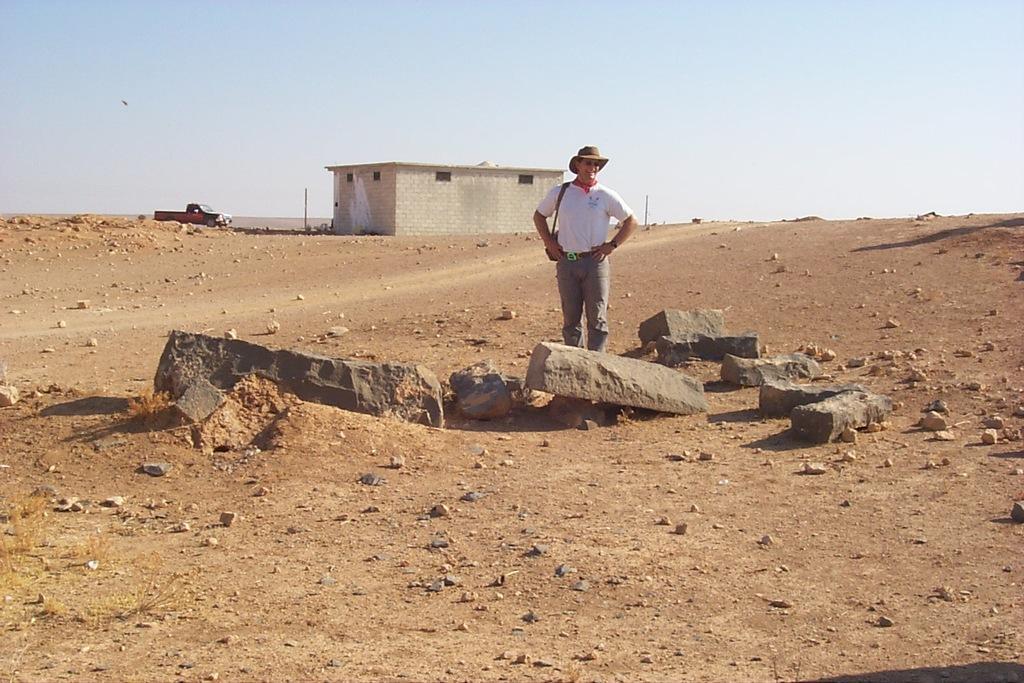Please provide a concise description of this image. In the background we can see the sky. In this picture we can see a vehicle, poles, house, stones and rocks. We can see a man wearing a hat, goggles and standing. We can see the strap of a bag on his shoulder. 